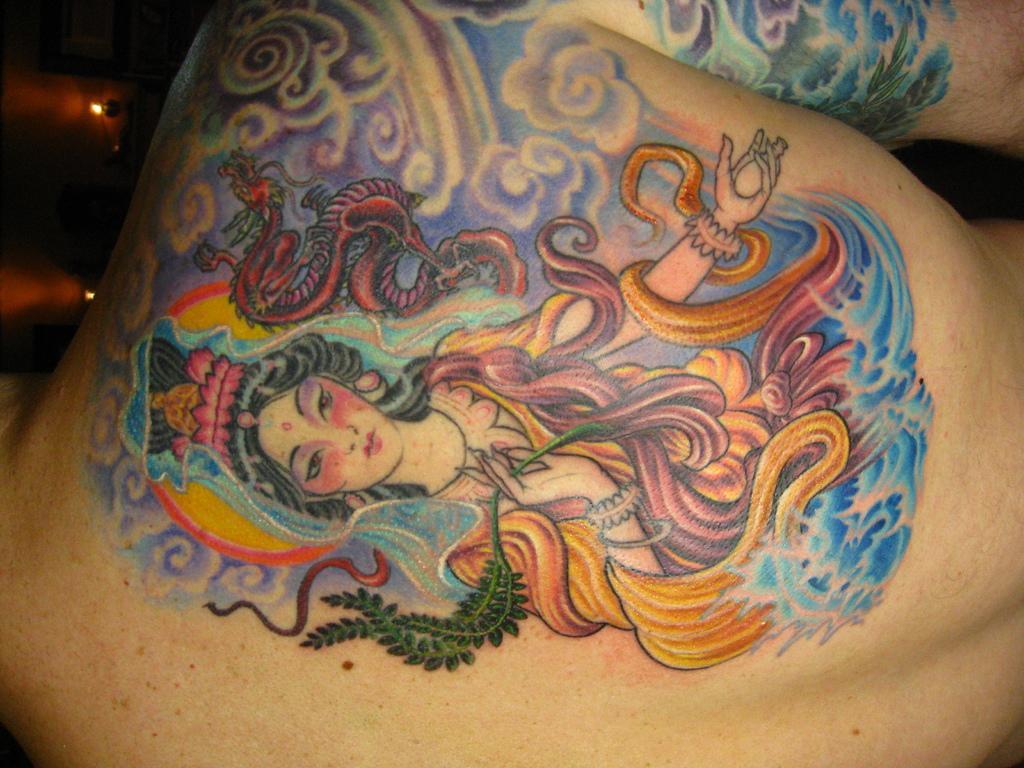Please provide a concise description of this image. In this image, we can see a tattoo on the back of a person. 